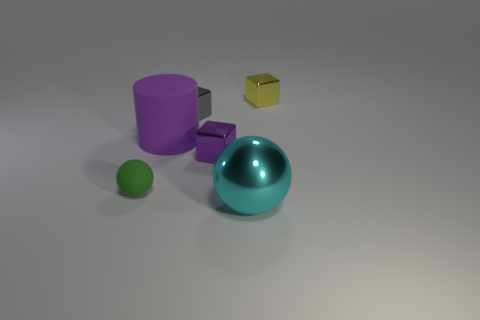The gray object that is the same material as the large sphere is what shape? The gray object sharing the same material qualities as the large sphere exhibits the geometric form of a cube, characterized by its six faces, each a perfect square, and its twelve equal edges converging at ninety-degree angles. 